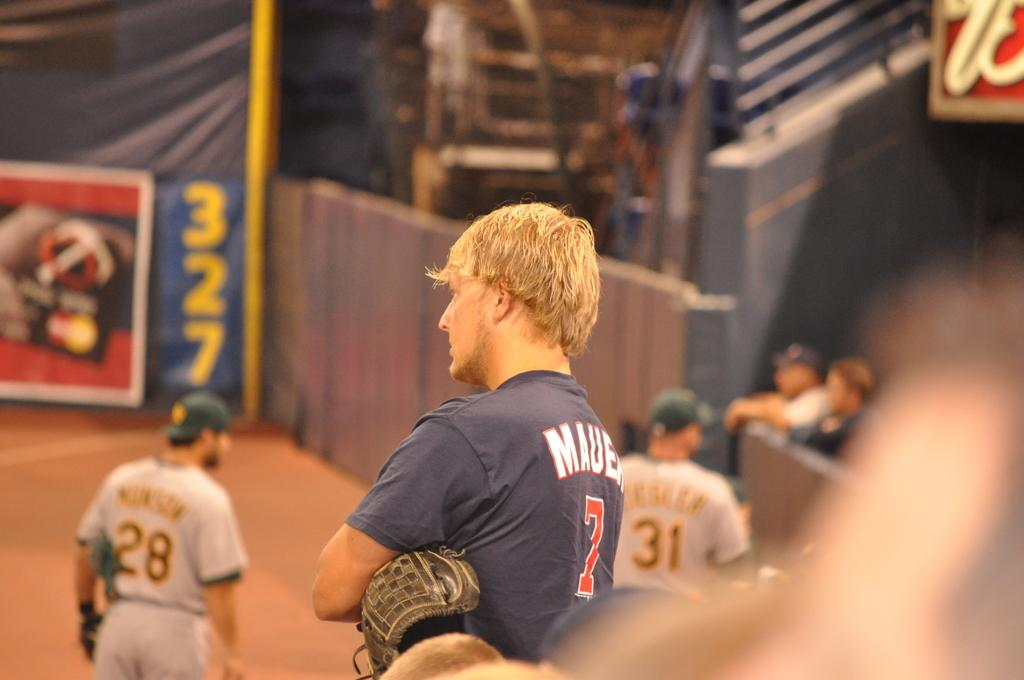<image>
Offer a succinct explanation of the picture presented. A baseball player wearing number thirty one stands in the distance. 